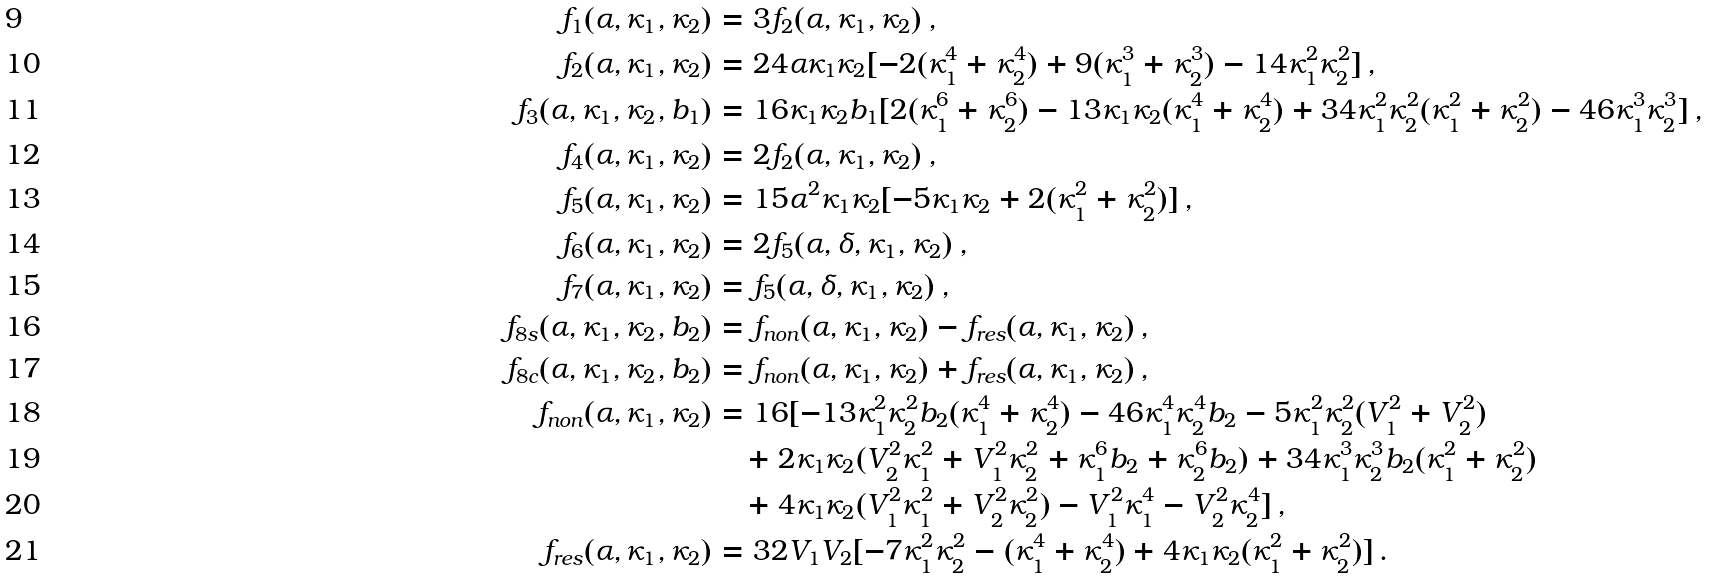<formula> <loc_0><loc_0><loc_500><loc_500>f _ { 1 } ( \alpha , \kappa _ { 1 } , \kappa _ { 2 } ) & = 3 f _ { 2 } ( \alpha , \kappa _ { 1 } , \kappa _ { 2 } ) \, , \\ f _ { 2 } ( \alpha , \kappa _ { 1 } , \kappa _ { 2 } ) & = 2 4 \alpha \kappa _ { 1 } \kappa _ { 2 } [ - 2 ( \kappa _ { 1 } ^ { 4 } + \kappa _ { 2 } ^ { 4 } ) + 9 ( \kappa _ { 1 } ^ { 3 } + \kappa _ { 2 } ^ { 3 } ) - 1 4 \kappa _ { 1 } ^ { 2 } \kappa _ { 2 } ^ { 2 } ] \, , \\ f _ { 3 } ( \alpha , \kappa _ { 1 } , \kappa _ { 2 } , b _ { 1 } ) & = 1 6 \kappa _ { 1 } \kappa _ { 2 } b _ { 1 } [ 2 ( \kappa _ { 1 } ^ { 6 } + \kappa _ { 2 } ^ { 6 } ) - 1 3 \kappa _ { 1 } \kappa _ { 2 } ( \kappa _ { 1 } ^ { 4 } + \kappa _ { 2 } ^ { 4 } ) + 3 4 \kappa _ { 1 } ^ { 2 } \kappa _ { 2 } ^ { 2 } ( \kappa _ { 1 } ^ { 2 } + \kappa _ { 2 } ^ { 2 } ) - 4 6 \kappa _ { 1 } ^ { 3 } \kappa _ { 2 } ^ { 3 } ] \, , \\ f _ { 4 } ( \alpha , \kappa _ { 1 } , \kappa _ { 2 } ) & = 2 f _ { 2 } ( \alpha , \kappa _ { 1 } , \kappa _ { 2 } ) \, , \\ f _ { 5 } ( \alpha , \kappa _ { 1 } , \kappa _ { 2 } ) & = 1 5 \alpha ^ { 2 } \kappa _ { 1 } \kappa _ { 2 } [ - 5 \kappa _ { 1 } \kappa _ { 2 } + 2 ( \kappa _ { 1 } ^ { 2 } + \kappa _ { 2 } ^ { 2 } ) ] \, , \\ f _ { 6 } ( \alpha , \kappa _ { 1 } , \kappa _ { 2 } ) & = 2 f _ { 5 } ( \alpha , \delta , \kappa _ { 1 } , \kappa _ { 2 } ) \, , \\ f _ { 7 } ( \alpha , \kappa _ { 1 } , \kappa _ { 2 } ) & = f _ { 5 } ( \alpha , \delta , \kappa _ { 1 } , \kappa _ { 2 } ) \, , \\ f _ { 8 s } ( \alpha , \kappa _ { 1 } , \kappa _ { 2 } , b _ { 2 } ) & = f _ { n o n } ( \alpha , \kappa _ { 1 } , \kappa _ { 2 } ) - f _ { r e s } ( \alpha , \kappa _ { 1 } , \kappa _ { 2 } ) \, , \\ f _ { 8 c } ( \alpha , \kappa _ { 1 } , \kappa _ { 2 } , b _ { 2 } ) & = f _ { n o n } ( \alpha , \kappa _ { 1 } , \kappa _ { 2 } ) + f _ { r e s } ( \alpha , \kappa _ { 1 } , \kappa _ { 2 } ) \, , \\ f _ { n o n } ( \alpha , \kappa _ { 1 } , \kappa _ { 2 } ) & = 1 6 [ - 1 3 \kappa _ { 1 } ^ { 2 } \kappa _ { 2 } ^ { 2 } b _ { 2 } ( \kappa _ { 1 } ^ { 4 } + \kappa _ { 2 } ^ { 4 } ) - 4 6 \kappa _ { 1 } ^ { 4 } \kappa _ { 2 } ^ { 4 } b _ { 2 } - 5 \kappa _ { 1 } ^ { 2 } \kappa _ { 2 } ^ { 2 } ( V _ { 1 } ^ { 2 } + V _ { 2 } ^ { 2 } ) \\ & \quad + 2 \kappa _ { 1 } \kappa _ { 2 } ( V _ { 2 } ^ { 2 } \kappa _ { 1 } ^ { 2 } + V _ { 1 } ^ { 2 } \kappa _ { 2 } ^ { 2 } + \kappa _ { 1 } ^ { 6 } b _ { 2 } + \kappa _ { 2 } ^ { 6 } b _ { 2 } ) + 3 4 \kappa _ { 1 } ^ { 3 } \kappa _ { 2 } ^ { 3 } b _ { 2 } ( \kappa _ { 1 } ^ { 2 } + \kappa _ { 2 } ^ { 2 } ) \\ & \quad + 4 \kappa _ { 1 } \kappa _ { 2 } ( V _ { 1 } ^ { 2 } \kappa _ { 1 } ^ { 2 } + V _ { 2 } ^ { 2 } \kappa _ { 2 } ^ { 2 } ) - V _ { 1 } ^ { 2 } \kappa _ { 1 } ^ { 4 } - V _ { 2 } ^ { 2 } \kappa _ { 2 } ^ { 4 } ] \, , \\ f _ { r e s } ( \alpha , \kappa _ { 1 } , \kappa _ { 2 } ) & = 3 2 V _ { 1 } V _ { 2 } [ - 7 \kappa _ { 1 } ^ { 2 } \kappa _ { 2 } ^ { 2 } - ( \kappa _ { 1 } ^ { 4 } + \kappa _ { 2 } ^ { 4 } ) + 4 \kappa _ { 1 } \kappa _ { 2 } ( \kappa _ { 1 } ^ { 2 } + \kappa _ { 2 } ^ { 2 } ) ] \, .</formula> 